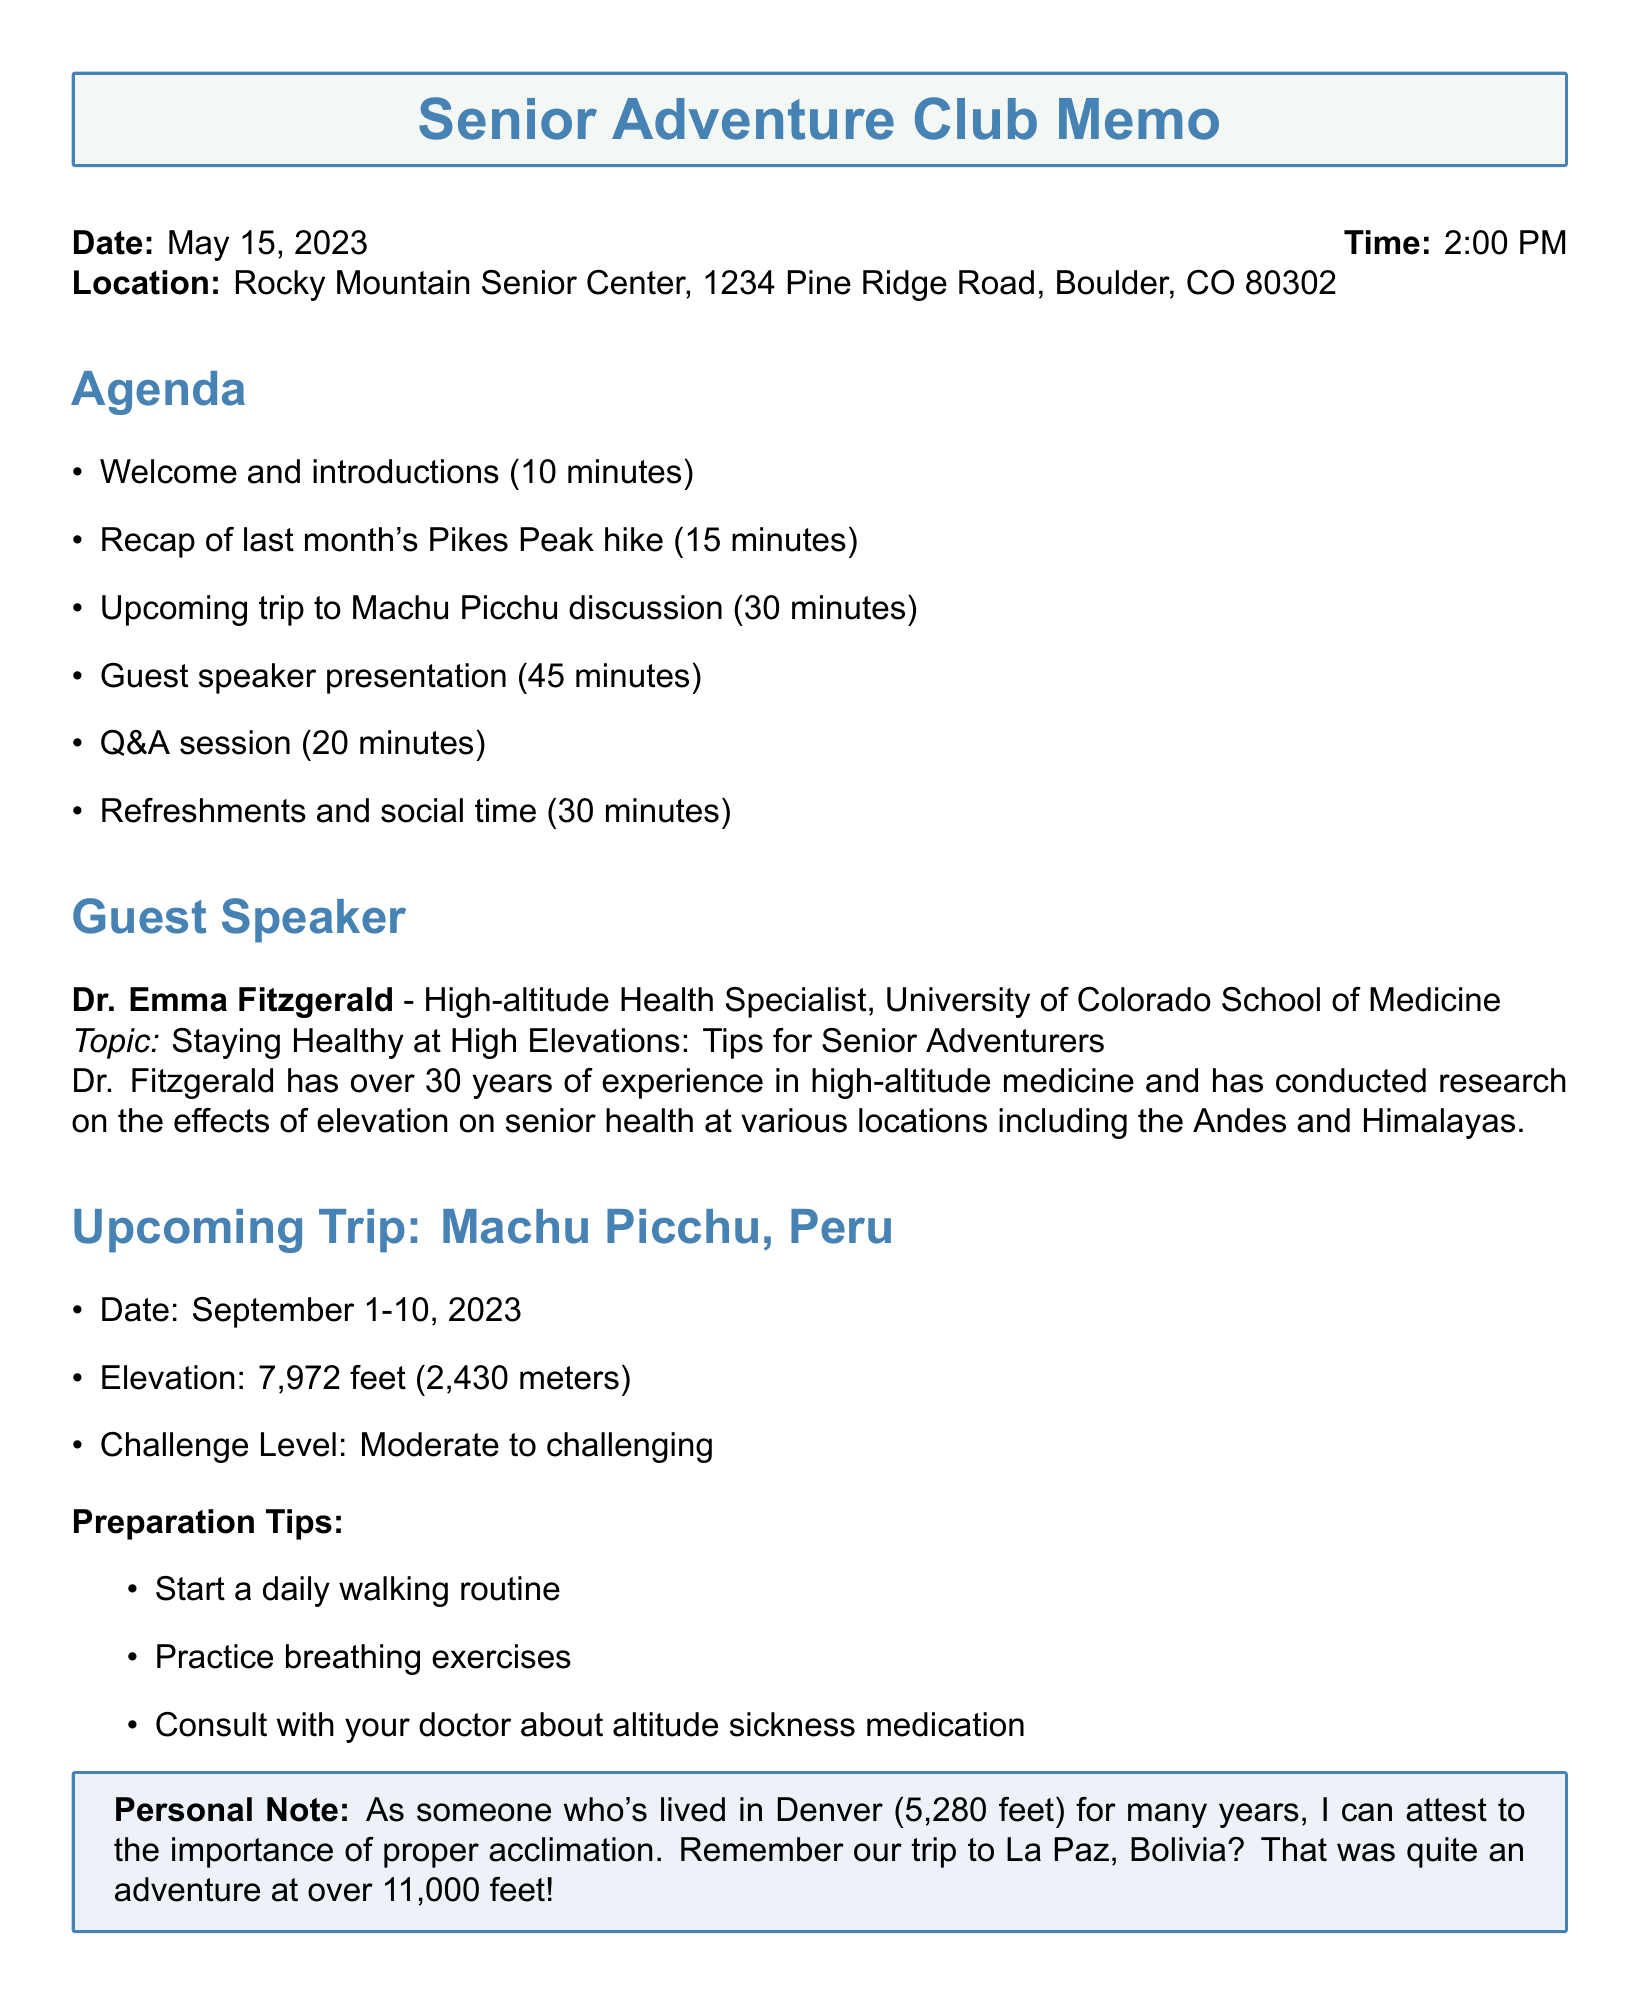What is the date of the meeting? The date of the meeting is stated in the meeting details section.
Answer: May 15, 2023 What time does the meeting start? The time of the meeting is provided alongside the date in the meeting details section.
Answer: 2:00 PM Who is the guest speaker? The name of the guest speaker is found in the guest speaker section.
Answer: Dr. Emma Fitzgerald What is the topic of the guest speaker's presentation? The topic is mentioned under the guest speaker's details.
Answer: Staying Healthy at High Elevations: Tips for Senior Adventurers What is the elevation of Machu Picchu? The elevation is specified in the upcoming trip section.
Answer: 7,972 feet (2,430 meters) What should participants bring to the meeting? One of the reminders indicates what participants should bring.
Answer: High-altitude adventure photos How long is the guest speaker's presentation? The duration of the guest speaker's presentation is listed in the agenda.
Answer: 45 minutes What is the preparation tip regarding breathing? This preparation tip is included in the section for the upcoming trip.
Answer: Practice breathing exercises What is the challenge level of the upcoming trip? The challenge level for the upcoming trip is specifically stated in that section.
Answer: Moderate to challenging 